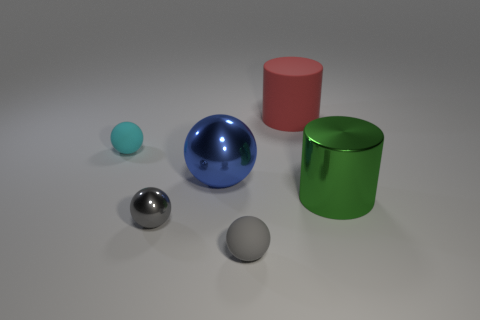Add 2 small cyan spheres. How many objects exist? 8 Subtract all cylinders. How many objects are left? 4 Subtract all large red rubber cubes. Subtract all large green metallic things. How many objects are left? 5 Add 6 small gray rubber balls. How many small gray rubber balls are left? 7 Add 1 cyan spheres. How many cyan spheres exist? 2 Subtract 1 green cylinders. How many objects are left? 5 